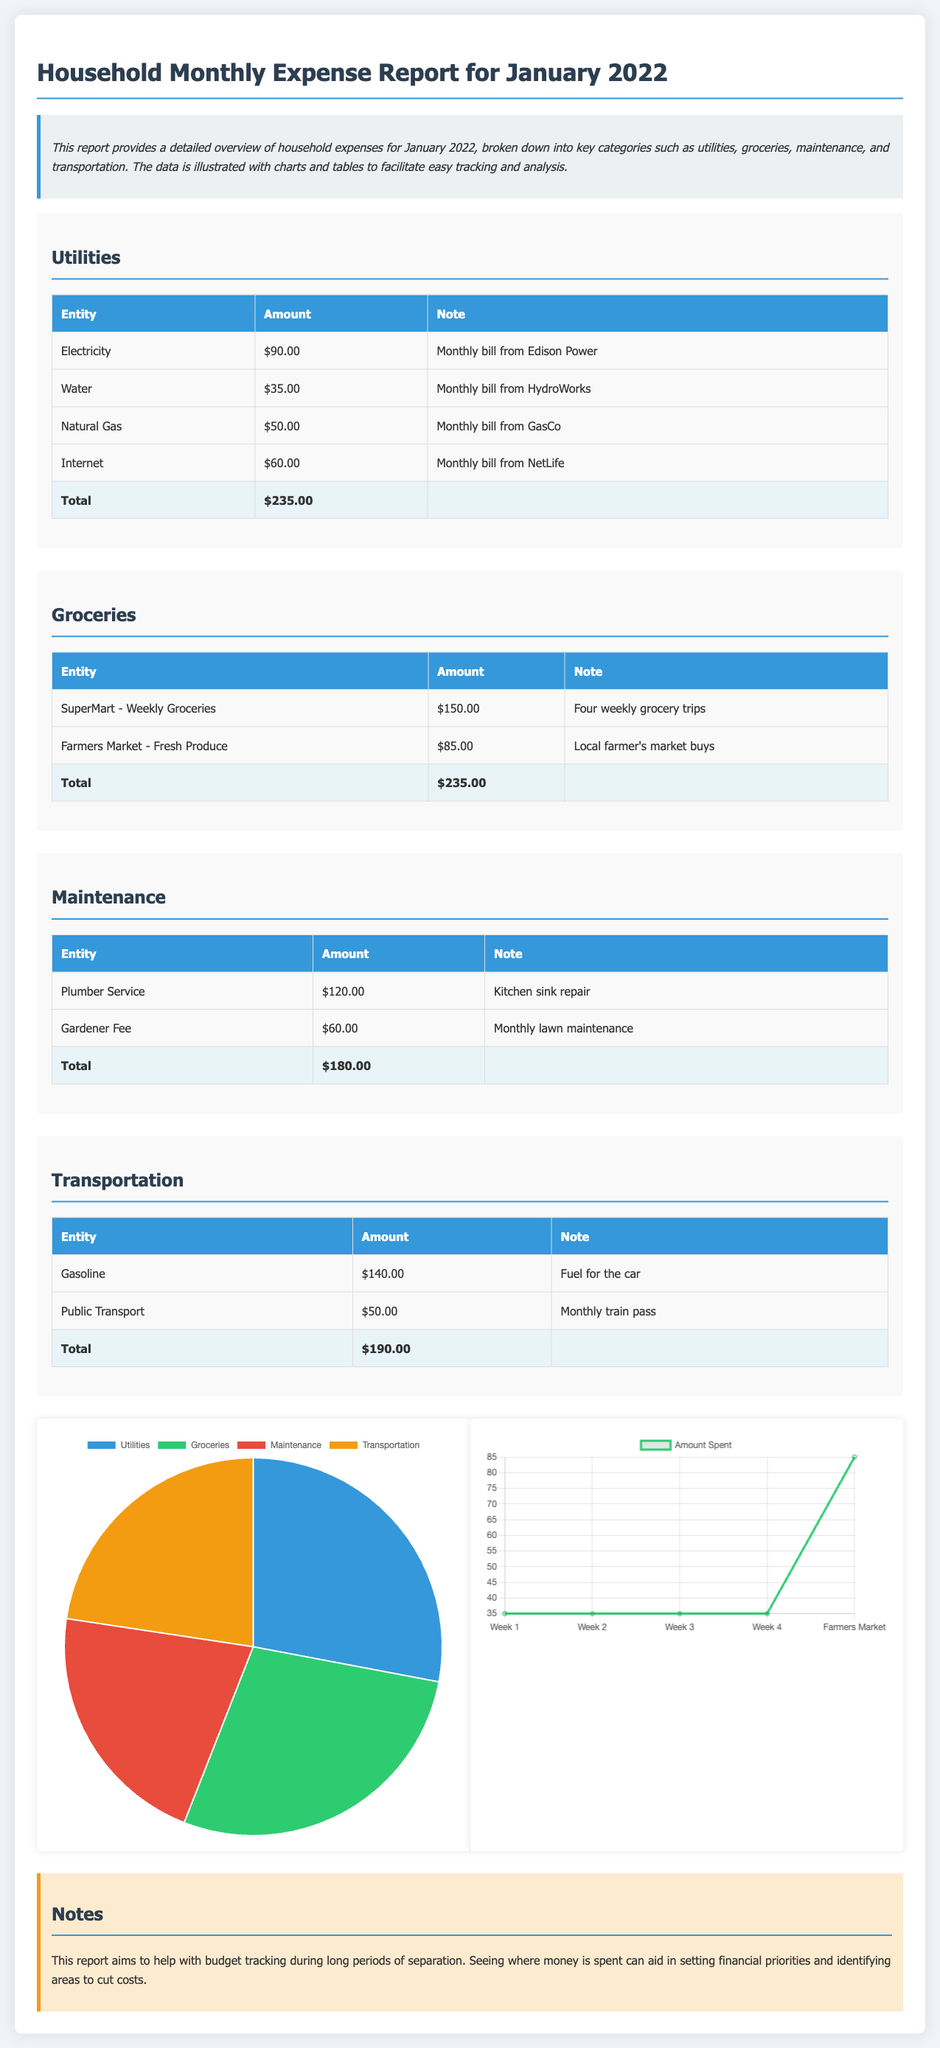What is the total amount spent on utilities? The total amount spent on utilities is calculated by adding the individual expenses: $90.00 + $35.00 + $50.00 + $60.00 = $235.00.
Answer: $235.00 How much was spent on groceries? The total amount spent on groceries is $150.00 + $85.00 = $235.00.
Answer: $235.00 What was the cost of the plumber service? The cost of the plumber service is the listed expense for repairing the kitchen sink, which is $120.00.
Answer: $120.00 What percentage of the total expenses does transportation represent? Transportation is $190.00, which is part of the total of $840.00. To find the percentage, $190.00 / $840.00 × 100 = approximately 22.62%.
Answer: 22.62% Which category had the highest expense? Among the listed categories, utilities, groceries, maintenance, and transportation, the category with the highest expense is utilities with $235.00.
Answer: Utilities What is the total amount for maintenance? The total amount for maintenance is calculated by adding the costs: $120.00 + $60.00 = $180.00.
Answer: $180.00 What is the purpose of the report? The report aims to provide an overview of household expenses, allowing for easy tracking and analysis of financial priorities during long separations.
Answer: Budget tracking Which chart represents the expense distribution? The chart representing the expense distribution is the pie chart labeled "January 2022 Expenses Distribution."
Answer: Pie chart How many weekly grocery trips were recorded? The report mentions four weekly grocery trips to SuperMart were recorded.
Answer: Four 